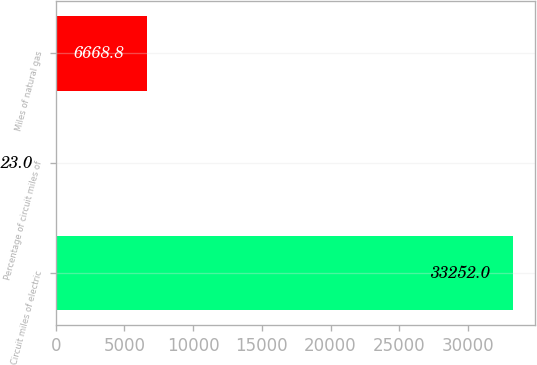Convert chart. <chart><loc_0><loc_0><loc_500><loc_500><bar_chart><fcel>Circuit miles of electric<fcel>Percentage of circuit miles of<fcel>Miles of natural gas<nl><fcel>33252<fcel>23<fcel>6668.8<nl></chart> 